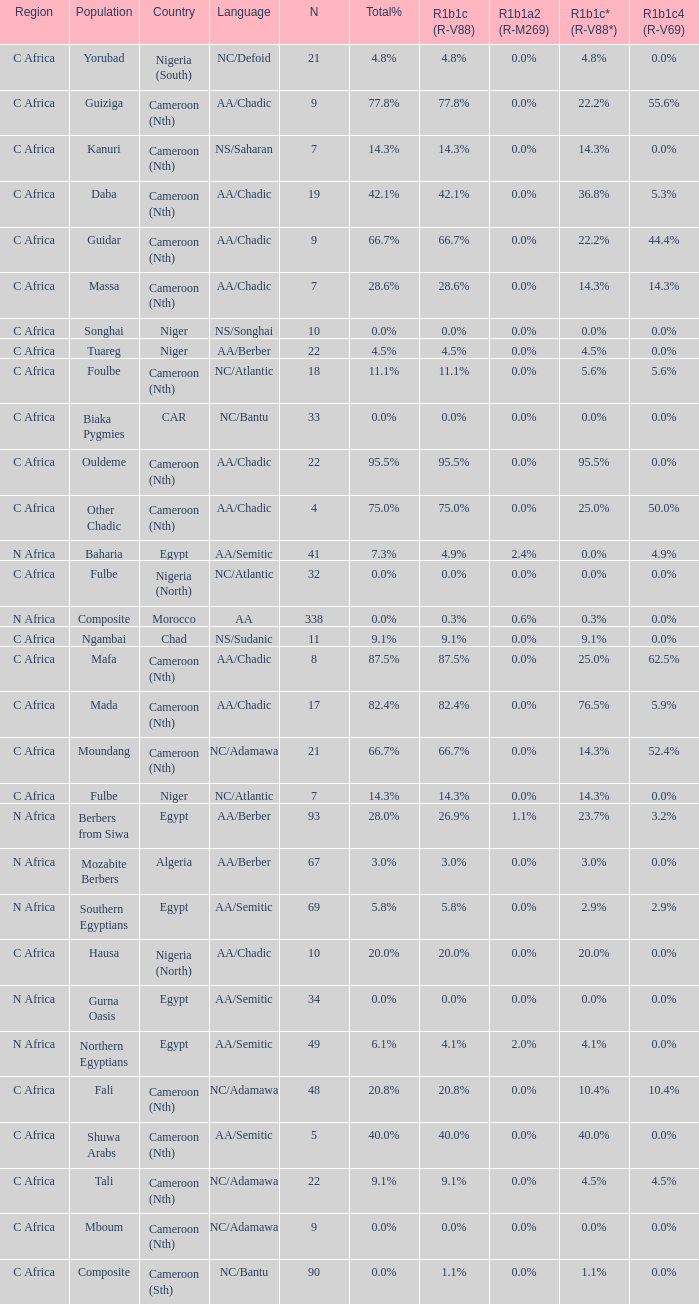Can you give me this table as a dict? {'header': ['Region', 'Population', 'Country', 'Language', 'N', 'Total%', 'R1b1c (R-V88)', 'R1b1a2 (R-M269)', 'R1b1c* (R-V88*)', 'R1b1c4 (R-V69)'], 'rows': [['C Africa', 'Yorubad', 'Nigeria (South)', 'NC/Defoid', '21', '4.8%', '4.8%', '0.0%', '4.8%', '0.0%'], ['C Africa', 'Guiziga', 'Cameroon (Nth)', 'AA/Chadic', '9', '77.8%', '77.8%', '0.0%', '22.2%', '55.6%'], ['C Africa', 'Kanuri', 'Cameroon (Nth)', 'NS/Saharan', '7', '14.3%', '14.3%', '0.0%', '14.3%', '0.0%'], ['C Africa', 'Daba', 'Cameroon (Nth)', 'AA/Chadic', '19', '42.1%', '42.1%', '0.0%', '36.8%', '5.3%'], ['C Africa', 'Guidar', 'Cameroon (Nth)', 'AA/Chadic', '9', '66.7%', '66.7%', '0.0%', '22.2%', '44.4%'], ['C Africa', 'Massa', 'Cameroon (Nth)', 'AA/Chadic', '7', '28.6%', '28.6%', '0.0%', '14.3%', '14.3%'], ['C Africa', 'Songhai', 'Niger', 'NS/Songhai', '10', '0.0%', '0.0%', '0.0%', '0.0%', '0.0%'], ['C Africa', 'Tuareg', 'Niger', 'AA/Berber', '22', '4.5%', '4.5%', '0.0%', '4.5%', '0.0%'], ['C Africa', 'Foulbe', 'Cameroon (Nth)', 'NC/Atlantic', '18', '11.1%', '11.1%', '0.0%', '5.6%', '5.6%'], ['C Africa', 'Biaka Pygmies', 'CAR', 'NC/Bantu', '33', '0.0%', '0.0%', '0.0%', '0.0%', '0.0%'], ['C Africa', 'Ouldeme', 'Cameroon (Nth)', 'AA/Chadic', '22', '95.5%', '95.5%', '0.0%', '95.5%', '0.0%'], ['C Africa', 'Other Chadic', 'Cameroon (Nth)', 'AA/Chadic', '4', '75.0%', '75.0%', '0.0%', '25.0%', '50.0%'], ['N Africa', 'Baharia', 'Egypt', 'AA/Semitic', '41', '7.3%', '4.9%', '2.4%', '0.0%', '4.9%'], ['C Africa', 'Fulbe', 'Nigeria (North)', 'NC/Atlantic', '32', '0.0%', '0.0%', '0.0%', '0.0%', '0.0%'], ['N Africa', 'Composite', 'Morocco', 'AA', '338', '0.0%', '0.3%', '0.6%', '0.3%', '0.0%'], ['C Africa', 'Ngambai', 'Chad', 'NS/Sudanic', '11', '9.1%', '9.1%', '0.0%', '9.1%', '0.0%'], ['C Africa', 'Mafa', 'Cameroon (Nth)', 'AA/Chadic', '8', '87.5%', '87.5%', '0.0%', '25.0%', '62.5%'], ['C Africa', 'Mada', 'Cameroon (Nth)', 'AA/Chadic', '17', '82.4%', '82.4%', '0.0%', '76.5%', '5.9%'], ['C Africa', 'Moundang', 'Cameroon (Nth)', 'NC/Adamawa', '21', '66.7%', '66.7%', '0.0%', '14.3%', '52.4%'], ['C Africa', 'Fulbe', 'Niger', 'NC/Atlantic', '7', '14.3%', '14.3%', '0.0%', '14.3%', '0.0%'], ['N Africa', 'Berbers from Siwa', 'Egypt', 'AA/Berber', '93', '28.0%', '26.9%', '1.1%', '23.7%', '3.2%'], ['N Africa', 'Mozabite Berbers', 'Algeria', 'AA/Berber', '67', '3.0%', '3.0%', '0.0%', '3.0%', '0.0%'], ['N Africa', 'Southern Egyptians', 'Egypt', 'AA/Semitic', '69', '5.8%', '5.8%', '0.0%', '2.9%', '2.9%'], ['C Africa', 'Hausa', 'Nigeria (North)', 'AA/Chadic', '10', '20.0%', '20.0%', '0.0%', '20.0%', '0.0%'], ['N Africa', 'Gurna Oasis', 'Egypt', 'AA/Semitic', '34', '0.0%', '0.0%', '0.0%', '0.0%', '0.0%'], ['N Africa', 'Northern Egyptians', 'Egypt', 'AA/Semitic', '49', '6.1%', '4.1%', '2.0%', '4.1%', '0.0%'], ['C Africa', 'Fali', 'Cameroon (Nth)', 'NC/Adamawa', '48', '20.8%', '20.8%', '0.0%', '10.4%', '10.4%'], ['C Africa', 'Shuwa Arabs', 'Cameroon (Nth)', 'AA/Semitic', '5', '40.0%', '40.0%', '0.0%', '40.0%', '0.0%'], ['C Africa', 'Tali', 'Cameroon (Nth)', 'NC/Adamawa', '22', '9.1%', '9.1%', '0.0%', '4.5%', '4.5%'], ['C Africa', 'Mboum', 'Cameroon (Nth)', 'NC/Adamawa', '9', '0.0%', '0.0%', '0.0%', '0.0%', '0.0%'], ['C Africa', 'Composite', 'Cameroon (Sth)', 'NC/Bantu', '90', '0.0%', '1.1%', '0.0%', '1.1%', '0.0%']]} What languages are spoken in Niger with r1b1c (r-v88) of 0.0%? NS/Songhai. 